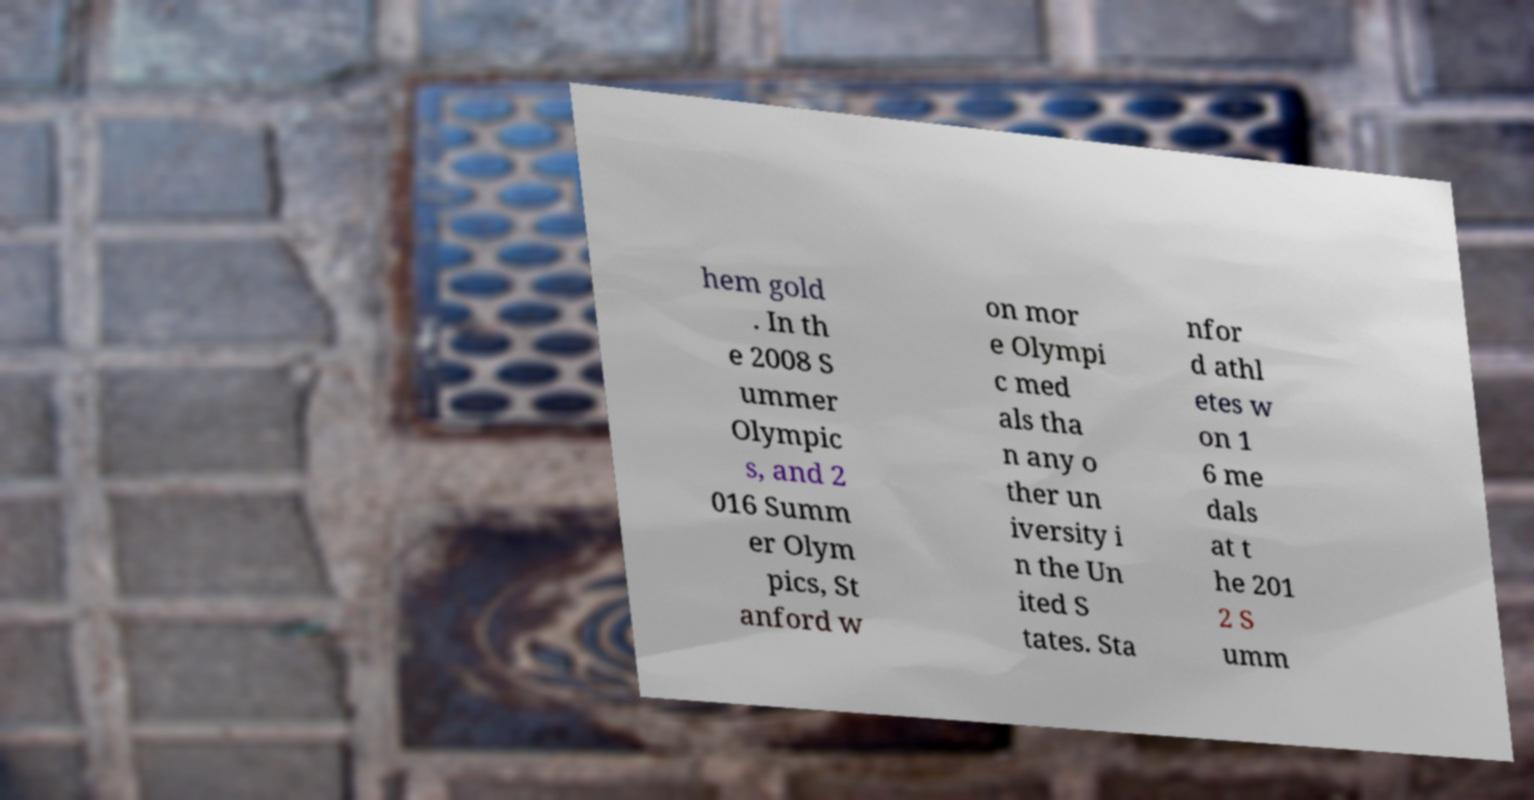I need the written content from this picture converted into text. Can you do that? hem gold . In th e 2008 S ummer Olympic s, and 2 016 Summ er Olym pics, St anford w on mor e Olympi c med als tha n any o ther un iversity i n the Un ited S tates. Sta nfor d athl etes w on 1 6 me dals at t he 201 2 S umm 